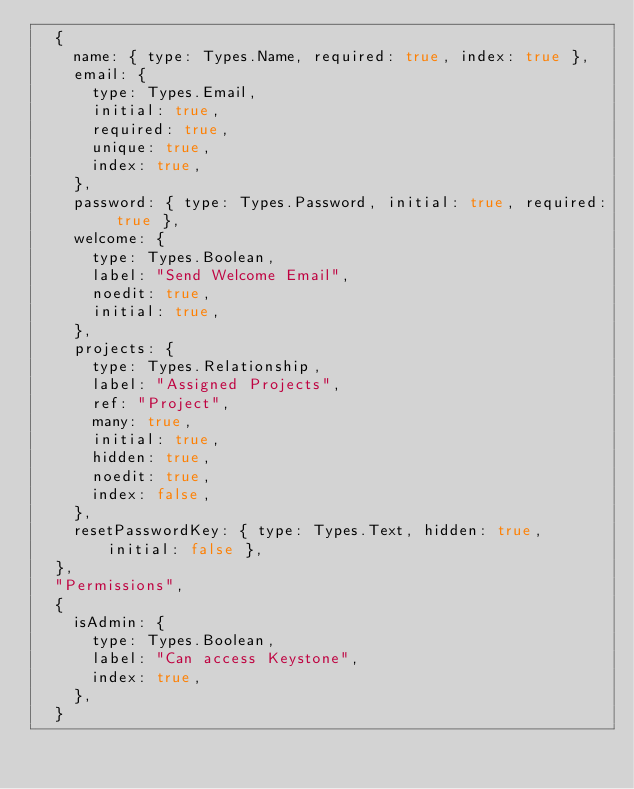Convert code to text. <code><loc_0><loc_0><loc_500><loc_500><_JavaScript_>	{
		name: { type: Types.Name, required: true, index: true },
		email: {
			type: Types.Email,
			initial: true,
			required: true,
			unique: true,
			index: true,
		},
		password: { type: Types.Password, initial: true, required: true },
		welcome: {
			type: Types.Boolean,
			label: "Send Welcome Email",
			noedit: true,
			initial: true,
		},
		projects: {
			type: Types.Relationship,
			label: "Assigned Projects",
			ref: "Project",
			many: true,
			initial: true,
			hidden: true,
			noedit: true,
			index: false,
		},
		resetPasswordKey: { type: Types.Text, hidden: true, initial: false },
	},
	"Permissions",
	{
		isAdmin: {
			type: Types.Boolean,
			label: "Can access Keystone",
			index: true,
		},
	}</code> 